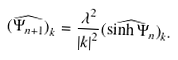Convert formula to latex. <formula><loc_0><loc_0><loc_500><loc_500>\widehat { ( \Psi _ { n + 1 } ) } _ { k } = \frac { \lambda ^ { 2 } } { { \left | { k } \right | } ^ { 2 } } \widehat { ( \sinh \Psi _ { n } ) } _ { k } .</formula> 